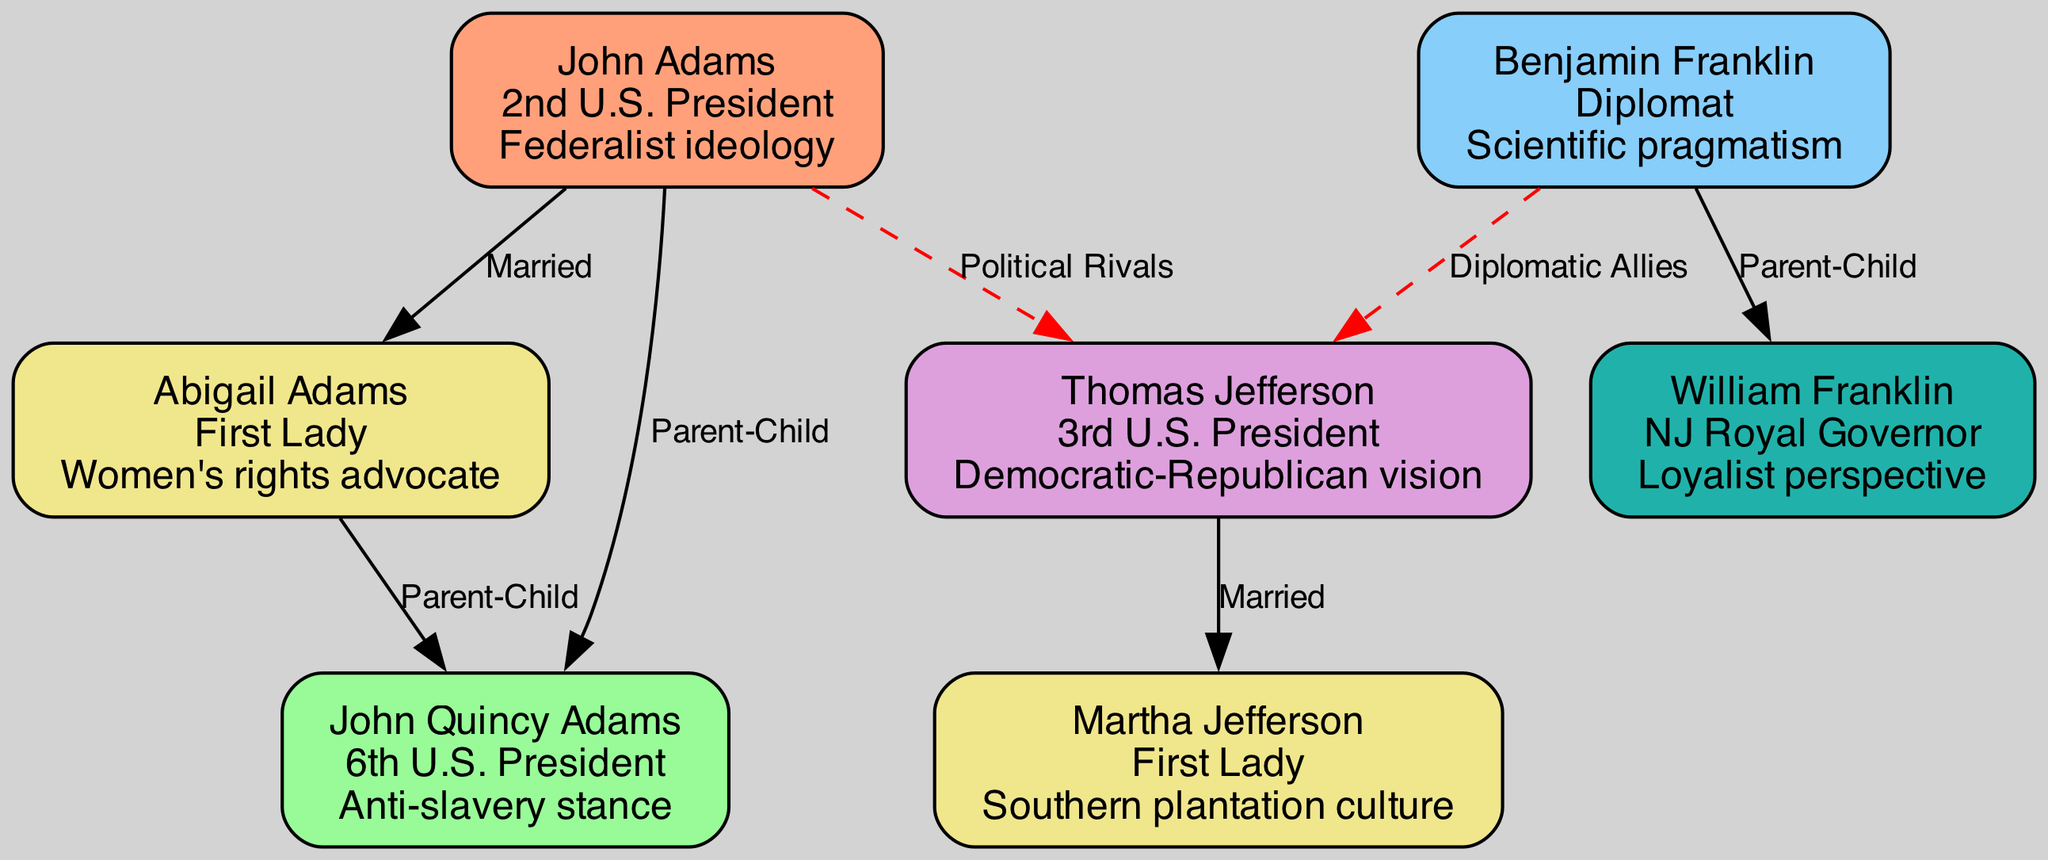What is John Adams' role? The diagram clearly indicates that John Adams is labeled as the "2nd U.S. President". This information can be found in the boxed section of the node connected to him.
Answer: 2nd U.S. President How many nodes are in the diagram? To find the total number of nodes, you can count each individual entry that represents a person in the family tree. In this case, there are 7 distinct nodes listed.
Answer: 7 Who is John Quincy Adams' parent? The diagram shows an edge depicting a "Parent-Child" relationship between John Adams and John Quincy Adams. This indicates that John Adams is the parent of John Quincy Adams.
Answer: John Adams What relationship does Thomas Jefferson have with Martha Jefferson? The relationship is explicitly labeled as "Married" in the diagram, indicating their spousal connection. The edge connecting these two nodes reflects this relationship.
Answer: Married Which individual has a loyalist perspective? Referring to the edge leading to William Franklin indicates his role and influence, which is stated as having a "Loyalist perspective". This connects him to Benjamin Franklin as his parent.
Answer: William Franklin How are John Adams and Thomas Jefferson connected in the diagram? In the diagram, John Adams and Thomas Jefferson are labeled as "Political Rivals." This relationship is denoted through a dashed line, indicating a more competitive link rather than a familial one.
Answer: Political Rivals Who is connected to both John Adams and Thomas Jefferson? The connection to both Adams and Jefferson points to various influences in their political rivalry. However, looking closely at the relationships listed, John Quincy Adams is the one influenced by the connections to John Adams.
Answer: John Quincy Adams What is Benjamin Franklin's role? The diagram highlights that Benjamin Franklin is a "Diplomat," and his influence includes "Scientific pragmatism," which is displayed prominently on his node.
Answer: Diplomat How many relationships are associated with Abigail Adams? By examining the edges related to Abigail Adams in the diagram, there are two direct connections: one with John Adams (Married) and another with John Quincy Adams (Parent-Child). This counts to a total of two relationships.
Answer: 2 